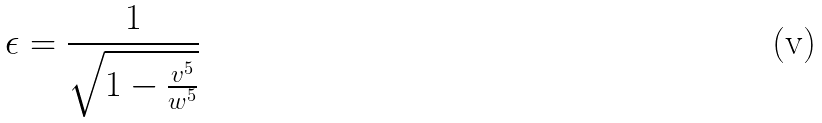Convert formula to latex. <formula><loc_0><loc_0><loc_500><loc_500>\epsilon = \frac { 1 } { \sqrt { 1 - \frac { v ^ { 5 } } { w ^ { 5 } } } }</formula> 